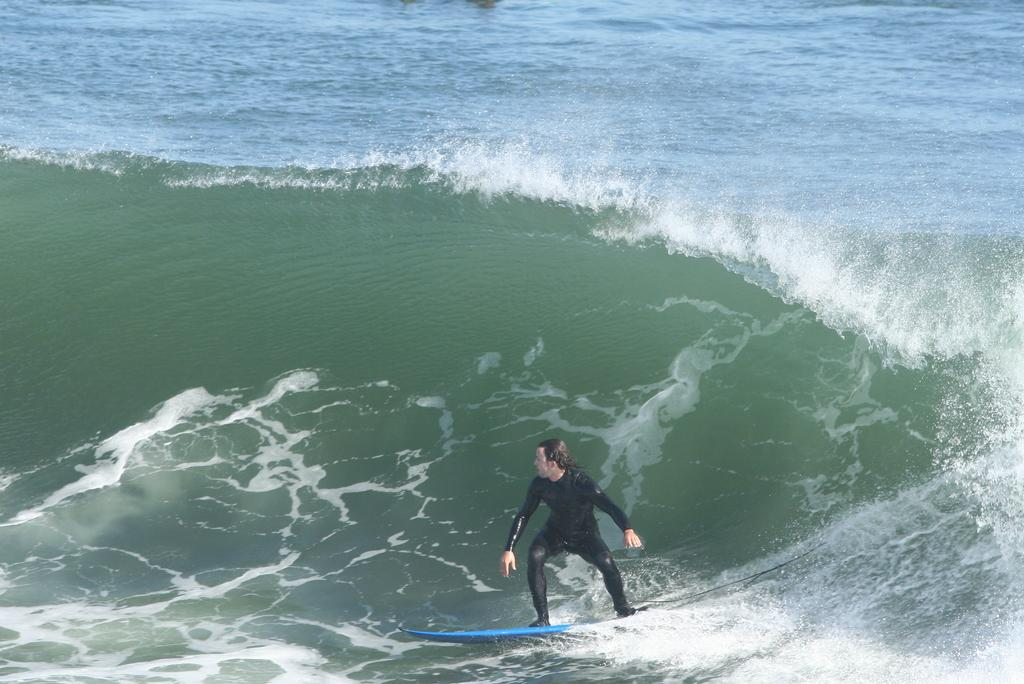What activity is the person in the image engaged in? The person is surfing in the image. What color is the swimsuit worn by the person? The person is wearing a black color swimsuit. What can be observed about the water in the image? There is a tide in the ocean. What type of amusement can be seen in the image? There is no amusement park or ride present in the image; it features a person surfing in the ocean. What direction is the person surfing in the image? The image does not provide information about the direction the person is surfing; it only shows the person riding a wave. 